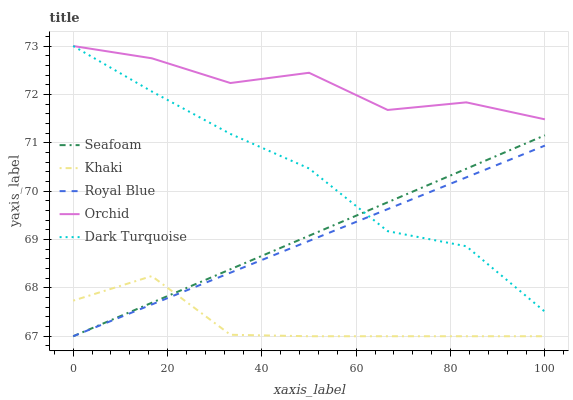Does Khaki have the minimum area under the curve?
Answer yes or no. Yes. Does Orchid have the maximum area under the curve?
Answer yes or no. Yes. Does Seafoam have the minimum area under the curve?
Answer yes or no. No. Does Seafoam have the maximum area under the curve?
Answer yes or no. No. Is Royal Blue the smoothest?
Answer yes or no. Yes. Is Orchid the roughest?
Answer yes or no. Yes. Is Khaki the smoothest?
Answer yes or no. No. Is Khaki the roughest?
Answer yes or no. No. Does Royal Blue have the lowest value?
Answer yes or no. Yes. Does Dark Turquoise have the lowest value?
Answer yes or no. No. Does Orchid have the highest value?
Answer yes or no. Yes. Does Seafoam have the highest value?
Answer yes or no. No. Is Royal Blue less than Orchid?
Answer yes or no. Yes. Is Orchid greater than Khaki?
Answer yes or no. Yes. Does Khaki intersect Seafoam?
Answer yes or no. Yes. Is Khaki less than Seafoam?
Answer yes or no. No. Is Khaki greater than Seafoam?
Answer yes or no. No. Does Royal Blue intersect Orchid?
Answer yes or no. No. 